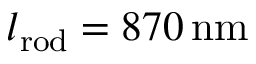<formula> <loc_0><loc_0><loc_500><loc_500>l _ { r o d } = 8 7 0 \, n m</formula> 